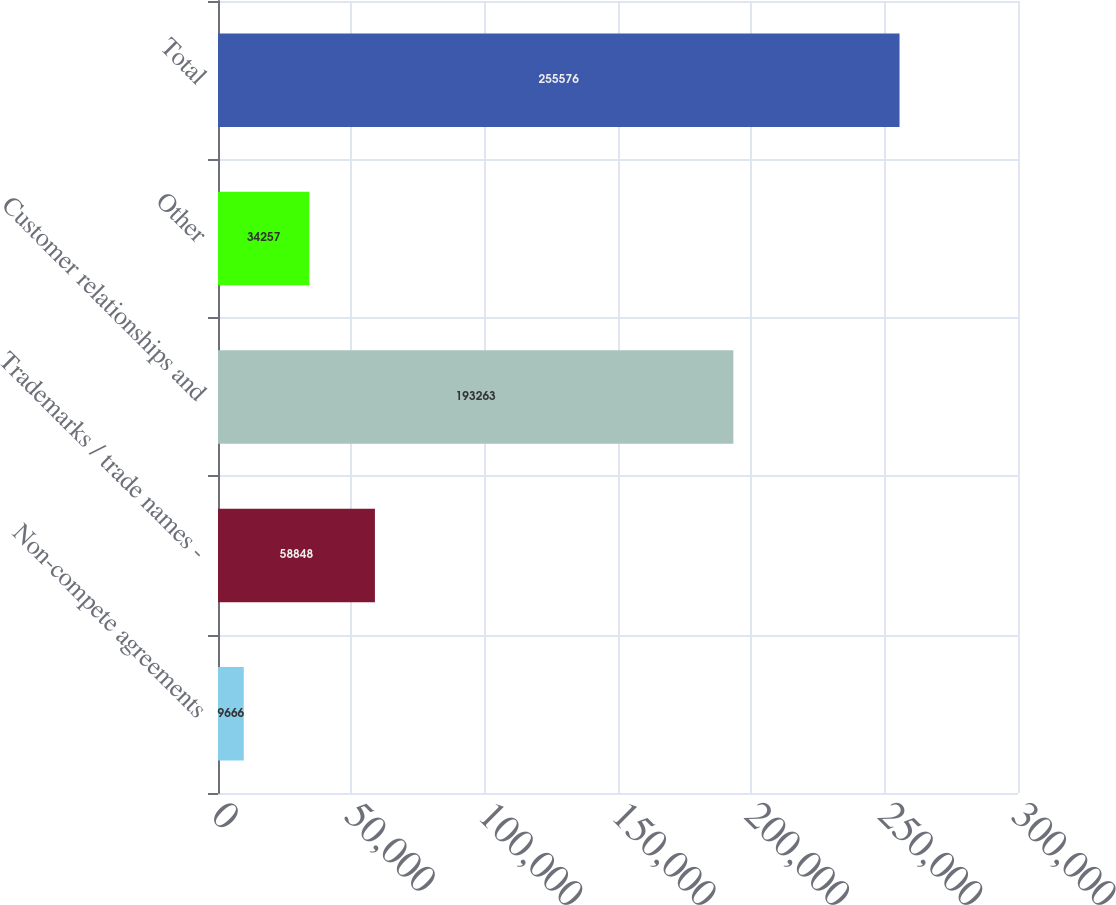Convert chart. <chart><loc_0><loc_0><loc_500><loc_500><bar_chart><fcel>Non-compete agreements<fcel>Trademarks / trade names -<fcel>Customer relationships and<fcel>Other<fcel>Total<nl><fcel>9666<fcel>58848<fcel>193263<fcel>34257<fcel>255576<nl></chart> 